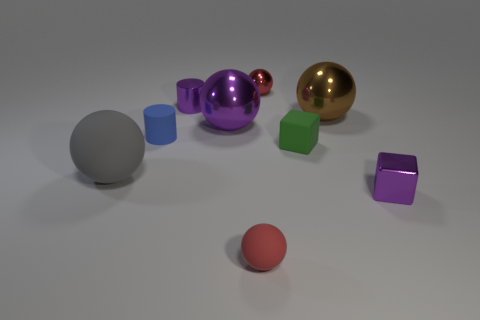There is a rubber object that is both right of the small blue cylinder and behind the tiny shiny cube; how big is it? The rubber object you're referring to appears to be medium-sized relative to the other items in the image. 